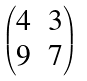Convert formula to latex. <formula><loc_0><loc_0><loc_500><loc_500>\begin{pmatrix} 4 & 3 \\ 9 & 7 \end{pmatrix}</formula> 